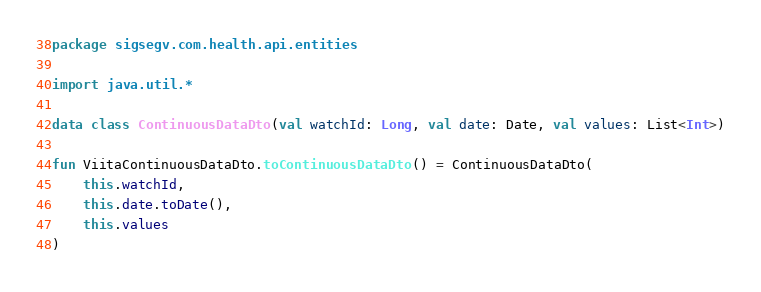<code> <loc_0><loc_0><loc_500><loc_500><_Kotlin_>package sigsegv.com.health.api.entities

import java.util.*

data class ContinuousDataDto(val watchId: Long, val date: Date, val values: List<Int>)

fun ViitaContinuousDataDto.toContinuousDataDto() = ContinuousDataDto(
    this.watchId,
    this.date.toDate(),
    this.values
)</code> 